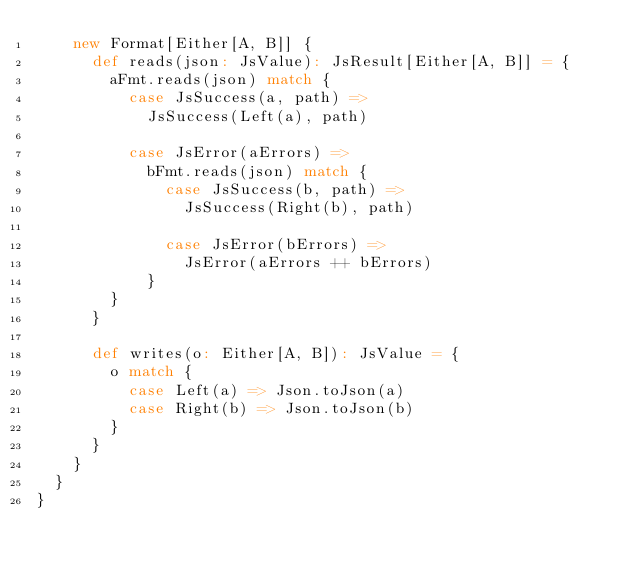<code> <loc_0><loc_0><loc_500><loc_500><_Scala_>    new Format[Either[A, B]] {
      def reads(json: JsValue): JsResult[Either[A, B]] = {
        aFmt.reads(json) match {
          case JsSuccess(a, path) =>
            JsSuccess(Left(a), path)

          case JsError(aErrors) =>
            bFmt.reads(json) match {
              case JsSuccess(b, path) =>
                JsSuccess(Right(b), path)

              case JsError(bErrors) =>
                JsError(aErrors ++ bErrors)
            }
        }
      }

      def writes(o: Either[A, B]): JsValue = {
        o match {
          case Left(a) => Json.toJson(a)
          case Right(b) => Json.toJson(b)
        }
      }
    }
  }
}
</code> 